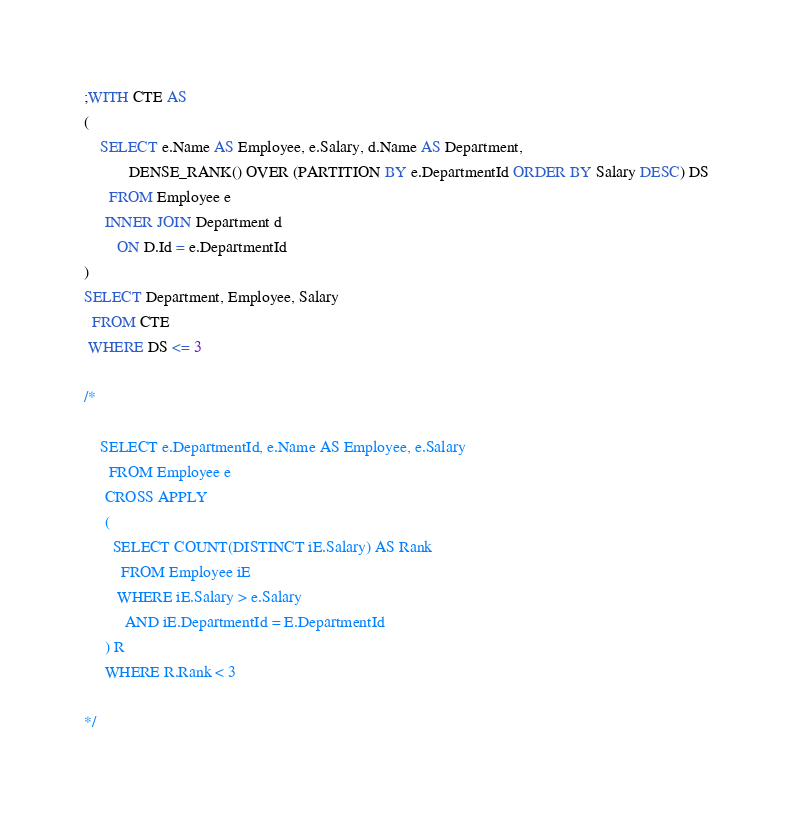<code> <loc_0><loc_0><loc_500><loc_500><_SQL_>;WITH CTE AS
(
    SELECT e.Name AS Employee, e.Salary, d.Name AS Department, 
           DENSE_RANK() OVER (PARTITION BY e.DepartmentId ORDER BY Salary DESC) DS
      FROM Employee e
     INNER JOIN Department d
        ON D.Id = e.DepartmentId
)
SELECT Department, Employee, Salary
  FROM CTE
 WHERE DS <= 3

/*

    SELECT e.DepartmentId, e.Name AS Employee, e.Salary
      FROM Employee e
     CROSS APPLY
     ( 
       SELECT COUNT(DISTINCT iE.Salary) AS Rank
         FROM Employee iE
        WHERE iE.Salary > e.Salary
          AND iE.DepartmentId = E.DepartmentId
     ) R
     WHERE R.Rank < 3 

*/
</code> 